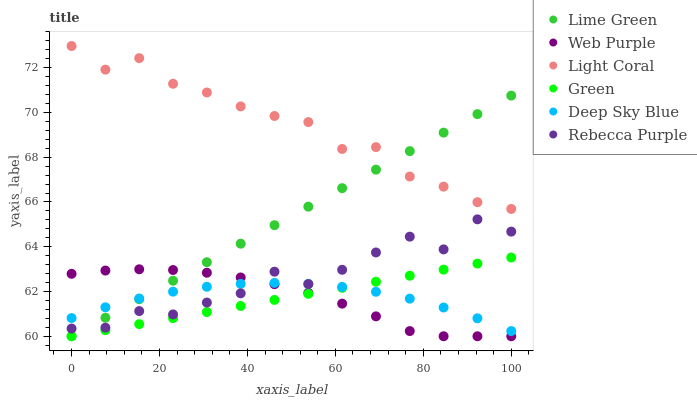Does Web Purple have the minimum area under the curve?
Answer yes or no. Yes. Does Light Coral have the maximum area under the curve?
Answer yes or no. Yes. Does Green have the minimum area under the curve?
Answer yes or no. No. Does Green have the maximum area under the curve?
Answer yes or no. No. Is Green the smoothest?
Answer yes or no. Yes. Is Rebecca Purple the roughest?
Answer yes or no. Yes. Is Web Purple the smoothest?
Answer yes or no. No. Is Web Purple the roughest?
Answer yes or no. No. Does Web Purple have the lowest value?
Answer yes or no. Yes. Does Rebecca Purple have the lowest value?
Answer yes or no. No. Does Light Coral have the highest value?
Answer yes or no. Yes. Does Web Purple have the highest value?
Answer yes or no. No. Is Deep Sky Blue less than Light Coral?
Answer yes or no. Yes. Is Light Coral greater than Rebecca Purple?
Answer yes or no. Yes. Does Lime Green intersect Green?
Answer yes or no. Yes. Is Lime Green less than Green?
Answer yes or no. No. Is Lime Green greater than Green?
Answer yes or no. No. Does Deep Sky Blue intersect Light Coral?
Answer yes or no. No. 